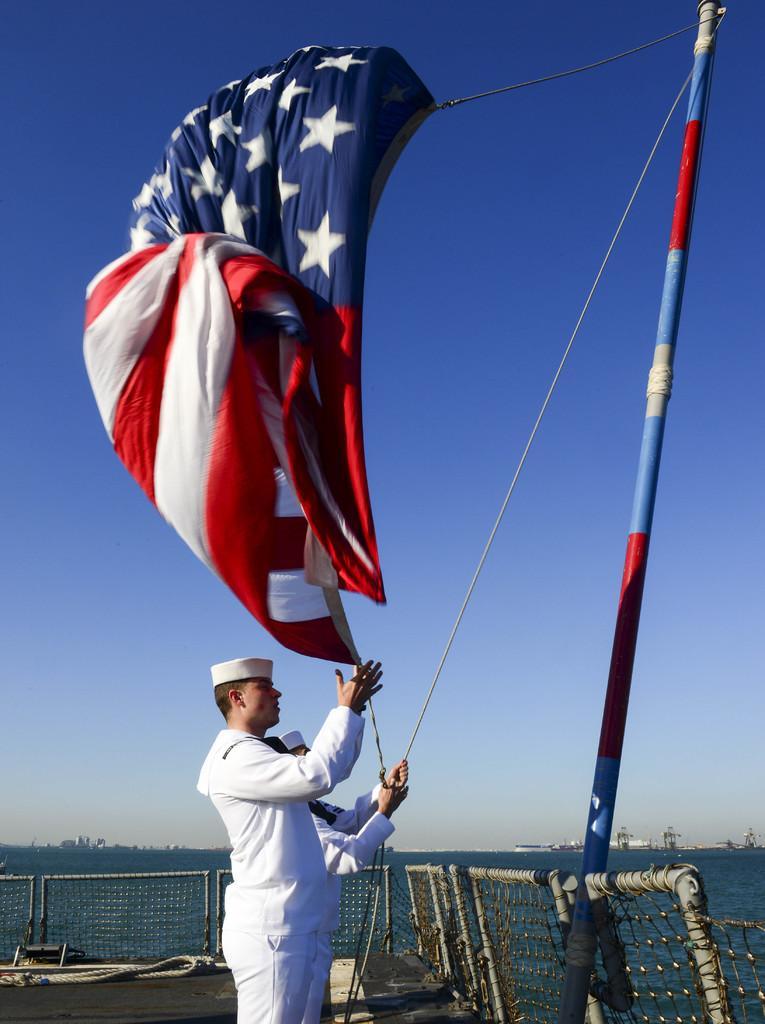Could you give a brief overview of what you see in this image? There are two persons wearing cap. One person is holding a rope and hoisting the flag on a pole. In the back there is fencing, water and sky. 